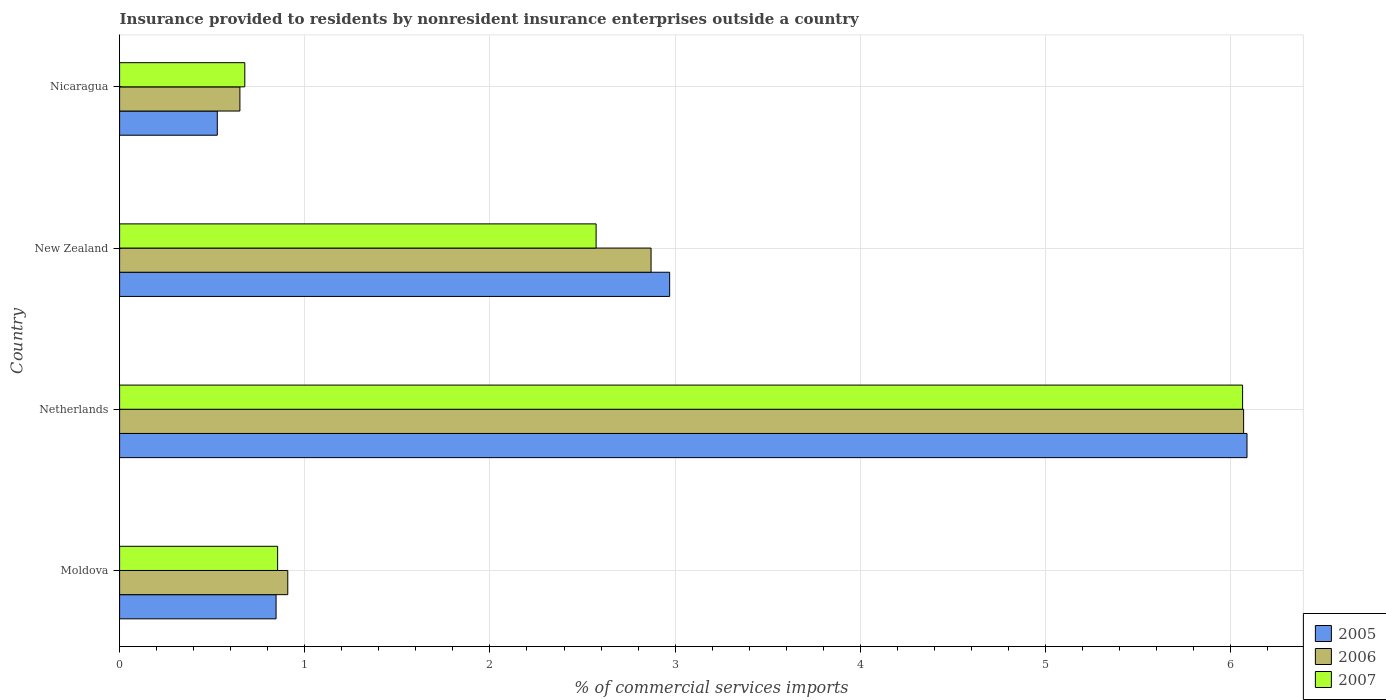How many different coloured bars are there?
Your answer should be very brief. 3. How many groups of bars are there?
Make the answer very short. 4. Are the number of bars on each tick of the Y-axis equal?
Your answer should be very brief. Yes. What is the label of the 3rd group of bars from the top?
Provide a succinct answer. Netherlands. What is the Insurance provided to residents in 2005 in Nicaragua?
Make the answer very short. 0.53. Across all countries, what is the maximum Insurance provided to residents in 2007?
Your answer should be compact. 6.06. Across all countries, what is the minimum Insurance provided to residents in 2006?
Offer a very short reply. 0.65. In which country was the Insurance provided to residents in 2007 maximum?
Your response must be concise. Netherlands. In which country was the Insurance provided to residents in 2006 minimum?
Offer a very short reply. Nicaragua. What is the total Insurance provided to residents in 2006 in the graph?
Ensure brevity in your answer.  10.5. What is the difference between the Insurance provided to residents in 2006 in Netherlands and that in Nicaragua?
Make the answer very short. 5.42. What is the difference between the Insurance provided to residents in 2006 in Nicaragua and the Insurance provided to residents in 2005 in Netherlands?
Provide a succinct answer. -5.44. What is the average Insurance provided to residents in 2006 per country?
Make the answer very short. 2.62. What is the difference between the Insurance provided to residents in 2007 and Insurance provided to residents in 2006 in Moldova?
Provide a succinct answer. -0.05. What is the ratio of the Insurance provided to residents in 2007 in Netherlands to that in Nicaragua?
Offer a very short reply. 8.97. Is the Insurance provided to residents in 2005 in Netherlands less than that in Nicaragua?
Your response must be concise. No. What is the difference between the highest and the second highest Insurance provided to residents in 2005?
Provide a succinct answer. 3.12. What is the difference between the highest and the lowest Insurance provided to residents in 2006?
Make the answer very short. 5.42. Is the sum of the Insurance provided to residents in 2005 in Netherlands and New Zealand greater than the maximum Insurance provided to residents in 2007 across all countries?
Give a very brief answer. Yes. What does the 2nd bar from the top in Netherlands represents?
Make the answer very short. 2006. How many bars are there?
Provide a succinct answer. 12. What is the difference between two consecutive major ticks on the X-axis?
Provide a short and direct response. 1. Are the values on the major ticks of X-axis written in scientific E-notation?
Ensure brevity in your answer.  No. Does the graph contain any zero values?
Provide a short and direct response. No. What is the title of the graph?
Provide a succinct answer. Insurance provided to residents by nonresident insurance enterprises outside a country. Does "1986" appear as one of the legend labels in the graph?
Offer a very short reply. No. What is the label or title of the X-axis?
Give a very brief answer. % of commercial services imports. What is the % of commercial services imports of 2005 in Moldova?
Keep it short and to the point. 0.85. What is the % of commercial services imports in 2006 in Moldova?
Provide a succinct answer. 0.91. What is the % of commercial services imports in 2007 in Moldova?
Ensure brevity in your answer.  0.85. What is the % of commercial services imports in 2005 in Netherlands?
Keep it short and to the point. 6.09. What is the % of commercial services imports in 2006 in Netherlands?
Make the answer very short. 6.07. What is the % of commercial services imports of 2007 in Netherlands?
Your answer should be compact. 6.06. What is the % of commercial services imports in 2005 in New Zealand?
Offer a very short reply. 2.97. What is the % of commercial services imports of 2006 in New Zealand?
Your response must be concise. 2.87. What is the % of commercial services imports in 2007 in New Zealand?
Make the answer very short. 2.57. What is the % of commercial services imports in 2005 in Nicaragua?
Provide a succinct answer. 0.53. What is the % of commercial services imports of 2006 in Nicaragua?
Offer a terse response. 0.65. What is the % of commercial services imports in 2007 in Nicaragua?
Make the answer very short. 0.68. Across all countries, what is the maximum % of commercial services imports of 2005?
Your answer should be very brief. 6.09. Across all countries, what is the maximum % of commercial services imports in 2006?
Provide a succinct answer. 6.07. Across all countries, what is the maximum % of commercial services imports in 2007?
Give a very brief answer. 6.06. Across all countries, what is the minimum % of commercial services imports in 2005?
Make the answer very short. 0.53. Across all countries, what is the minimum % of commercial services imports in 2006?
Your response must be concise. 0.65. Across all countries, what is the minimum % of commercial services imports of 2007?
Give a very brief answer. 0.68. What is the total % of commercial services imports of 2005 in the graph?
Provide a short and direct response. 10.43. What is the total % of commercial services imports in 2006 in the graph?
Ensure brevity in your answer.  10.5. What is the total % of commercial services imports of 2007 in the graph?
Your response must be concise. 10.17. What is the difference between the % of commercial services imports in 2005 in Moldova and that in Netherlands?
Offer a very short reply. -5.24. What is the difference between the % of commercial services imports in 2006 in Moldova and that in Netherlands?
Provide a short and direct response. -5.16. What is the difference between the % of commercial services imports in 2007 in Moldova and that in Netherlands?
Keep it short and to the point. -5.21. What is the difference between the % of commercial services imports of 2005 in Moldova and that in New Zealand?
Ensure brevity in your answer.  -2.13. What is the difference between the % of commercial services imports of 2006 in Moldova and that in New Zealand?
Your answer should be very brief. -1.96. What is the difference between the % of commercial services imports in 2007 in Moldova and that in New Zealand?
Offer a terse response. -1.72. What is the difference between the % of commercial services imports of 2005 in Moldova and that in Nicaragua?
Make the answer very short. 0.32. What is the difference between the % of commercial services imports of 2006 in Moldova and that in Nicaragua?
Provide a succinct answer. 0.26. What is the difference between the % of commercial services imports of 2007 in Moldova and that in Nicaragua?
Ensure brevity in your answer.  0.18. What is the difference between the % of commercial services imports of 2005 in Netherlands and that in New Zealand?
Make the answer very short. 3.12. What is the difference between the % of commercial services imports of 2006 in Netherlands and that in New Zealand?
Your response must be concise. 3.2. What is the difference between the % of commercial services imports in 2007 in Netherlands and that in New Zealand?
Keep it short and to the point. 3.49. What is the difference between the % of commercial services imports in 2005 in Netherlands and that in Nicaragua?
Offer a terse response. 5.56. What is the difference between the % of commercial services imports of 2006 in Netherlands and that in Nicaragua?
Your answer should be very brief. 5.42. What is the difference between the % of commercial services imports of 2007 in Netherlands and that in Nicaragua?
Your answer should be very brief. 5.39. What is the difference between the % of commercial services imports of 2005 in New Zealand and that in Nicaragua?
Keep it short and to the point. 2.44. What is the difference between the % of commercial services imports in 2006 in New Zealand and that in Nicaragua?
Offer a terse response. 2.22. What is the difference between the % of commercial services imports of 2007 in New Zealand and that in Nicaragua?
Provide a short and direct response. 1.9. What is the difference between the % of commercial services imports in 2005 in Moldova and the % of commercial services imports in 2006 in Netherlands?
Ensure brevity in your answer.  -5.23. What is the difference between the % of commercial services imports in 2005 in Moldova and the % of commercial services imports in 2007 in Netherlands?
Give a very brief answer. -5.22. What is the difference between the % of commercial services imports of 2006 in Moldova and the % of commercial services imports of 2007 in Netherlands?
Your answer should be very brief. -5.16. What is the difference between the % of commercial services imports of 2005 in Moldova and the % of commercial services imports of 2006 in New Zealand?
Offer a very short reply. -2.03. What is the difference between the % of commercial services imports of 2005 in Moldova and the % of commercial services imports of 2007 in New Zealand?
Provide a short and direct response. -1.73. What is the difference between the % of commercial services imports in 2006 in Moldova and the % of commercial services imports in 2007 in New Zealand?
Provide a short and direct response. -1.67. What is the difference between the % of commercial services imports in 2005 in Moldova and the % of commercial services imports in 2006 in Nicaragua?
Your answer should be very brief. 0.2. What is the difference between the % of commercial services imports of 2005 in Moldova and the % of commercial services imports of 2007 in Nicaragua?
Keep it short and to the point. 0.17. What is the difference between the % of commercial services imports of 2006 in Moldova and the % of commercial services imports of 2007 in Nicaragua?
Provide a succinct answer. 0.23. What is the difference between the % of commercial services imports in 2005 in Netherlands and the % of commercial services imports in 2006 in New Zealand?
Make the answer very short. 3.22. What is the difference between the % of commercial services imports of 2005 in Netherlands and the % of commercial services imports of 2007 in New Zealand?
Your answer should be very brief. 3.52. What is the difference between the % of commercial services imports in 2006 in Netherlands and the % of commercial services imports in 2007 in New Zealand?
Keep it short and to the point. 3.5. What is the difference between the % of commercial services imports in 2005 in Netherlands and the % of commercial services imports in 2006 in Nicaragua?
Offer a terse response. 5.44. What is the difference between the % of commercial services imports of 2005 in Netherlands and the % of commercial services imports of 2007 in Nicaragua?
Offer a terse response. 5.41. What is the difference between the % of commercial services imports of 2006 in Netherlands and the % of commercial services imports of 2007 in Nicaragua?
Ensure brevity in your answer.  5.39. What is the difference between the % of commercial services imports of 2005 in New Zealand and the % of commercial services imports of 2006 in Nicaragua?
Your answer should be very brief. 2.32. What is the difference between the % of commercial services imports in 2005 in New Zealand and the % of commercial services imports in 2007 in Nicaragua?
Offer a very short reply. 2.29. What is the difference between the % of commercial services imports in 2006 in New Zealand and the % of commercial services imports in 2007 in Nicaragua?
Offer a very short reply. 2.19. What is the average % of commercial services imports of 2005 per country?
Provide a short and direct response. 2.61. What is the average % of commercial services imports of 2006 per country?
Provide a succinct answer. 2.62. What is the average % of commercial services imports in 2007 per country?
Your response must be concise. 2.54. What is the difference between the % of commercial services imports of 2005 and % of commercial services imports of 2006 in Moldova?
Your answer should be compact. -0.06. What is the difference between the % of commercial services imports in 2005 and % of commercial services imports in 2007 in Moldova?
Make the answer very short. -0.01. What is the difference between the % of commercial services imports in 2006 and % of commercial services imports in 2007 in Moldova?
Offer a very short reply. 0.05. What is the difference between the % of commercial services imports in 2005 and % of commercial services imports in 2006 in Netherlands?
Provide a short and direct response. 0.02. What is the difference between the % of commercial services imports in 2005 and % of commercial services imports in 2007 in Netherlands?
Your response must be concise. 0.02. What is the difference between the % of commercial services imports of 2006 and % of commercial services imports of 2007 in Netherlands?
Make the answer very short. 0.01. What is the difference between the % of commercial services imports of 2005 and % of commercial services imports of 2006 in New Zealand?
Your answer should be compact. 0.1. What is the difference between the % of commercial services imports of 2005 and % of commercial services imports of 2007 in New Zealand?
Offer a terse response. 0.4. What is the difference between the % of commercial services imports in 2006 and % of commercial services imports in 2007 in New Zealand?
Your response must be concise. 0.3. What is the difference between the % of commercial services imports of 2005 and % of commercial services imports of 2006 in Nicaragua?
Provide a short and direct response. -0.12. What is the difference between the % of commercial services imports in 2005 and % of commercial services imports in 2007 in Nicaragua?
Your response must be concise. -0.15. What is the difference between the % of commercial services imports of 2006 and % of commercial services imports of 2007 in Nicaragua?
Offer a terse response. -0.03. What is the ratio of the % of commercial services imports of 2005 in Moldova to that in Netherlands?
Your answer should be very brief. 0.14. What is the ratio of the % of commercial services imports in 2006 in Moldova to that in Netherlands?
Your answer should be very brief. 0.15. What is the ratio of the % of commercial services imports of 2007 in Moldova to that in Netherlands?
Your response must be concise. 0.14. What is the ratio of the % of commercial services imports in 2005 in Moldova to that in New Zealand?
Offer a very short reply. 0.28. What is the ratio of the % of commercial services imports of 2006 in Moldova to that in New Zealand?
Your response must be concise. 0.32. What is the ratio of the % of commercial services imports of 2007 in Moldova to that in New Zealand?
Provide a succinct answer. 0.33. What is the ratio of the % of commercial services imports of 2005 in Moldova to that in Nicaragua?
Offer a terse response. 1.6. What is the ratio of the % of commercial services imports of 2006 in Moldova to that in Nicaragua?
Offer a terse response. 1.4. What is the ratio of the % of commercial services imports in 2007 in Moldova to that in Nicaragua?
Make the answer very short. 1.26. What is the ratio of the % of commercial services imports of 2005 in Netherlands to that in New Zealand?
Provide a short and direct response. 2.05. What is the ratio of the % of commercial services imports of 2006 in Netherlands to that in New Zealand?
Keep it short and to the point. 2.12. What is the ratio of the % of commercial services imports in 2007 in Netherlands to that in New Zealand?
Make the answer very short. 2.36. What is the ratio of the % of commercial services imports in 2005 in Netherlands to that in Nicaragua?
Provide a short and direct response. 11.54. What is the ratio of the % of commercial services imports of 2006 in Netherlands to that in Nicaragua?
Your answer should be compact. 9.34. What is the ratio of the % of commercial services imports of 2007 in Netherlands to that in Nicaragua?
Ensure brevity in your answer.  8.97. What is the ratio of the % of commercial services imports of 2005 in New Zealand to that in Nicaragua?
Provide a short and direct response. 5.63. What is the ratio of the % of commercial services imports in 2006 in New Zealand to that in Nicaragua?
Your answer should be very brief. 4.42. What is the ratio of the % of commercial services imports of 2007 in New Zealand to that in Nicaragua?
Offer a very short reply. 3.81. What is the difference between the highest and the second highest % of commercial services imports in 2005?
Provide a short and direct response. 3.12. What is the difference between the highest and the second highest % of commercial services imports in 2006?
Your answer should be very brief. 3.2. What is the difference between the highest and the second highest % of commercial services imports of 2007?
Provide a succinct answer. 3.49. What is the difference between the highest and the lowest % of commercial services imports of 2005?
Provide a succinct answer. 5.56. What is the difference between the highest and the lowest % of commercial services imports in 2006?
Offer a terse response. 5.42. What is the difference between the highest and the lowest % of commercial services imports in 2007?
Make the answer very short. 5.39. 